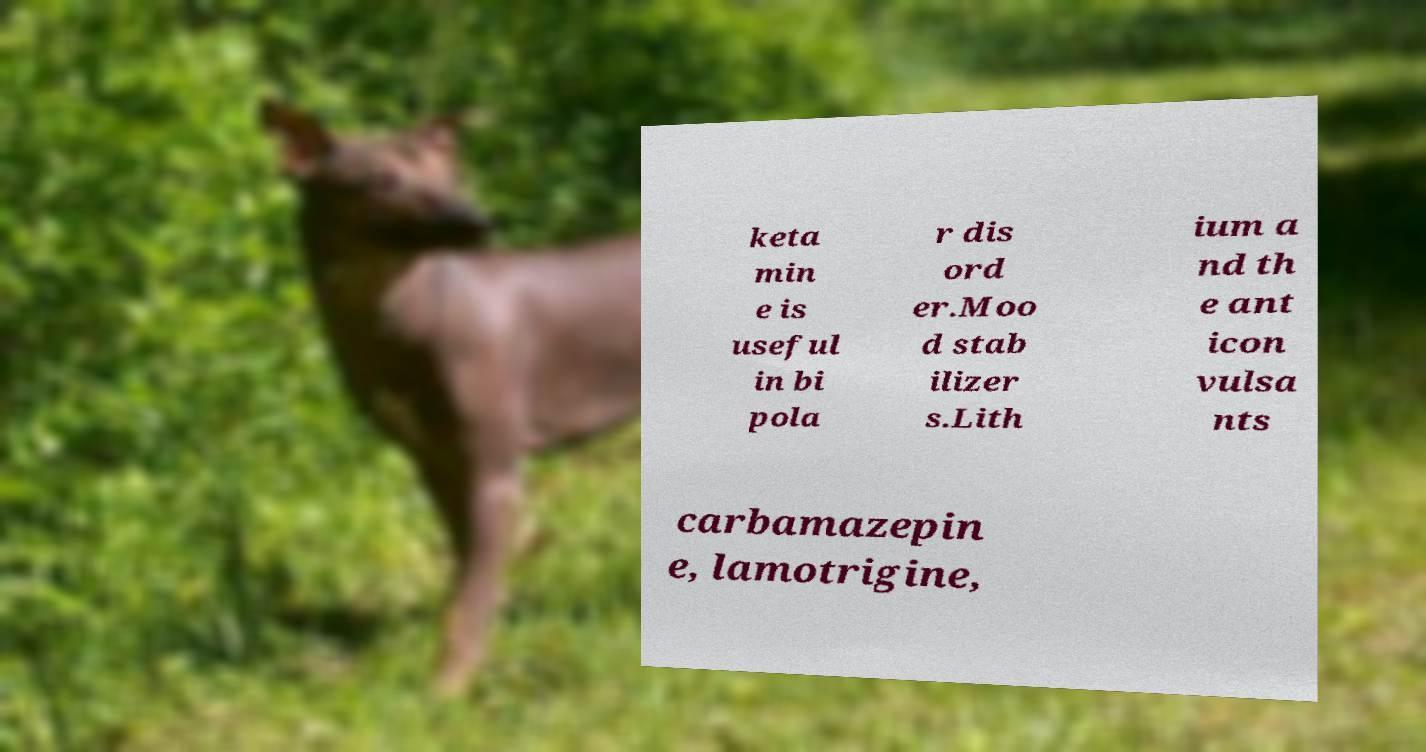What messages or text are displayed in this image? I need them in a readable, typed format. keta min e is useful in bi pola r dis ord er.Moo d stab ilizer s.Lith ium a nd th e ant icon vulsa nts carbamazepin e, lamotrigine, 